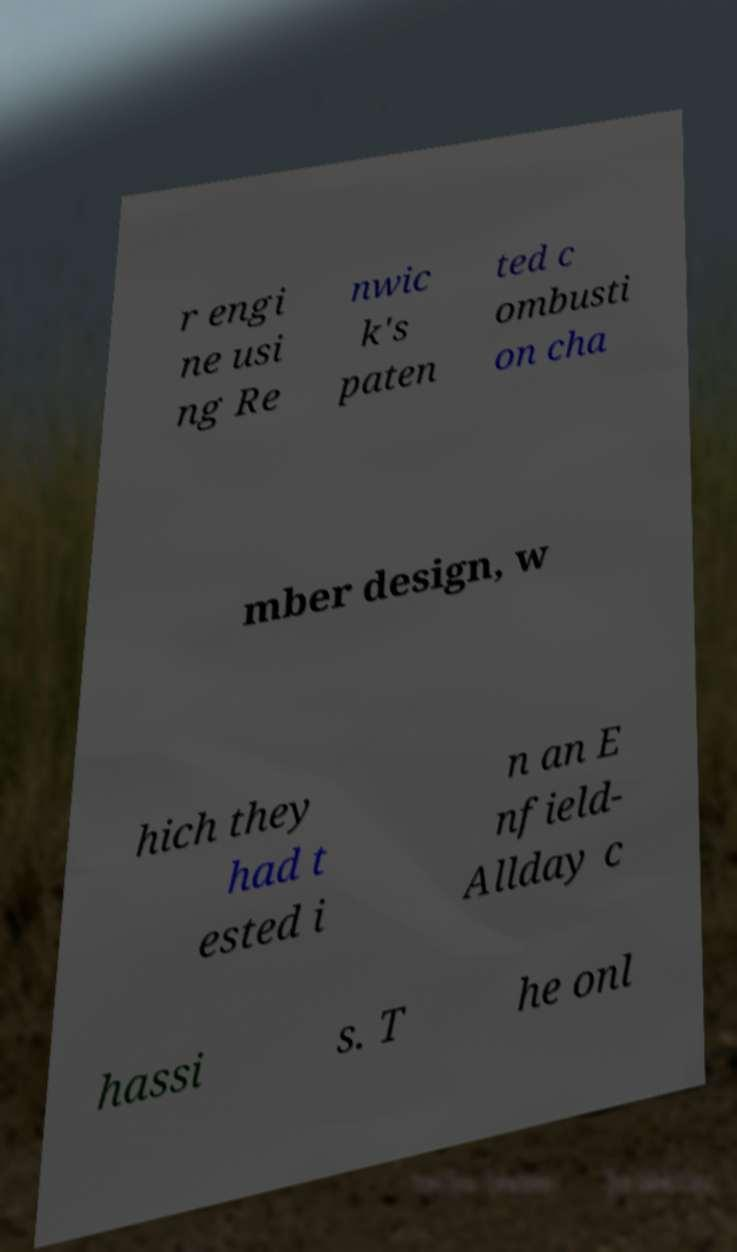What messages or text are displayed in this image? I need them in a readable, typed format. r engi ne usi ng Re nwic k's paten ted c ombusti on cha mber design, w hich they had t ested i n an E nfield- Allday c hassi s. T he onl 